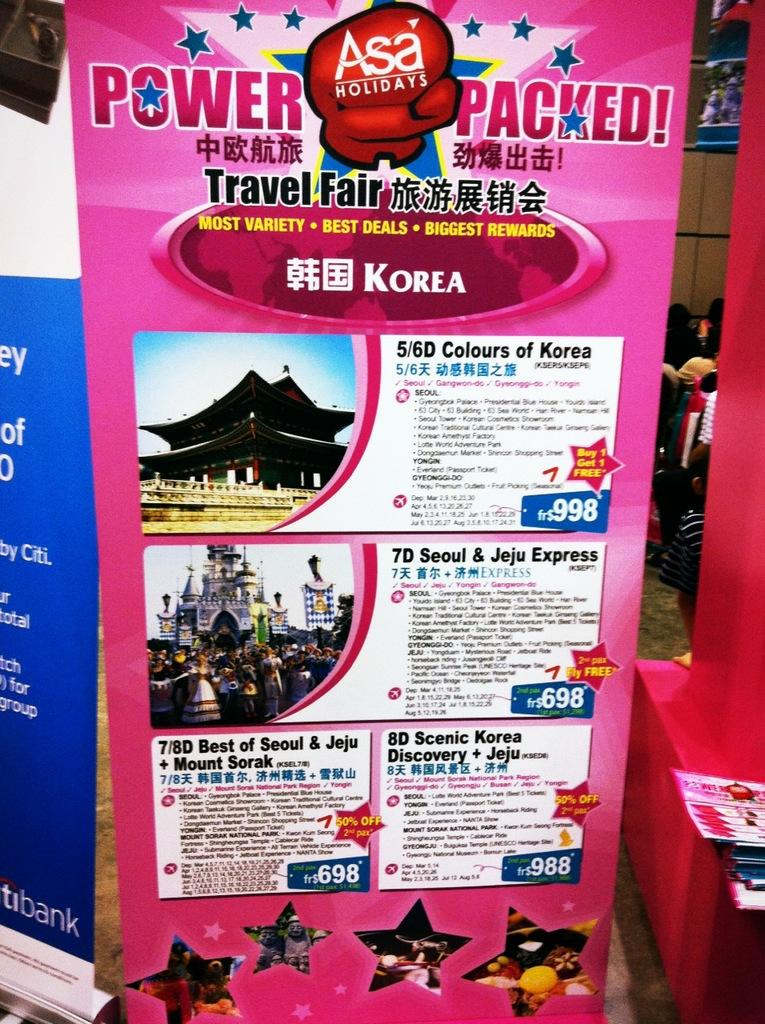Provide a one-sentence caption for the provided image. A travel poster titled Power Packed advertises several holiday offerings. 